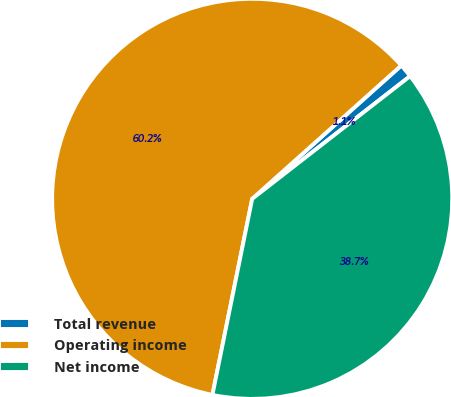<chart> <loc_0><loc_0><loc_500><loc_500><pie_chart><fcel>Total revenue<fcel>Operating income<fcel>Net income<nl><fcel>1.1%<fcel>60.2%<fcel>38.7%<nl></chart> 